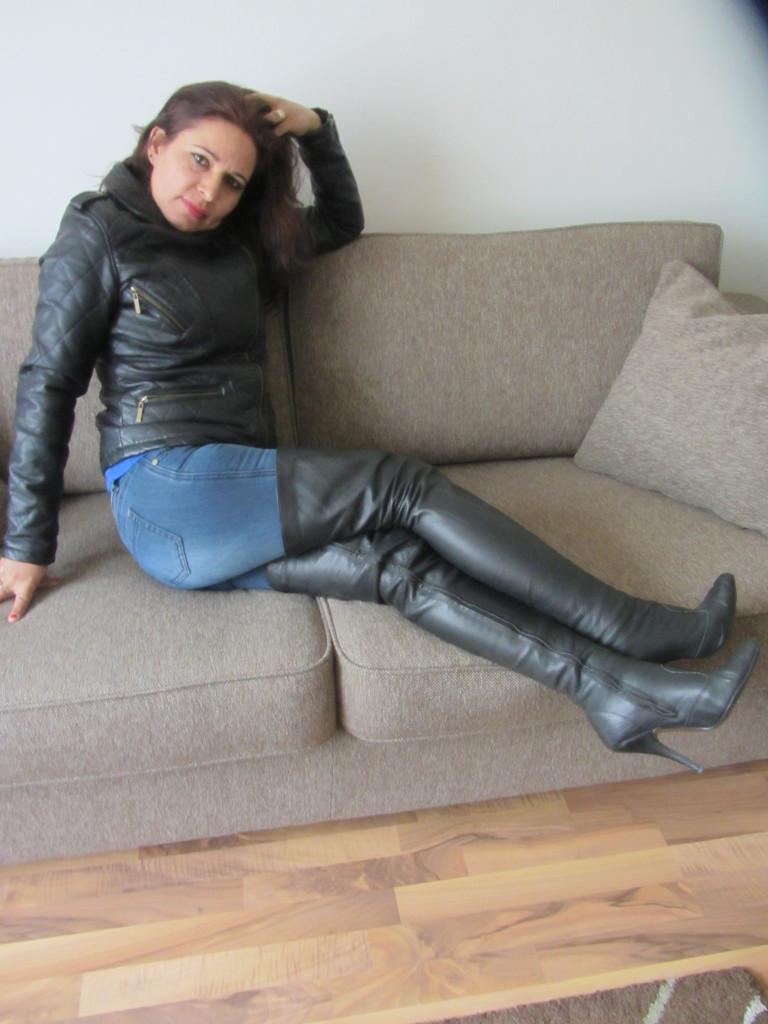Who is present in the image? There is a woman in the image. What is the woman doing in the image? The woman is sitting on a couch. What can be seen behind the couch in the image? There is a wall behind the couch. What type of bomb can be seen on the woman's lap in the image? There is no bomb present in the image; the woman is simply sitting on a couch. 